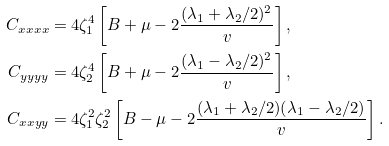<formula> <loc_0><loc_0><loc_500><loc_500>C _ { x x x x } & = 4 \zeta _ { 1 } ^ { 4 } \left [ B + \mu - 2 \frac { ( \lambda _ { 1 } + \lambda _ { 2 } / 2 ) ^ { 2 } } { v } \right ] , \\ C _ { y y y y } & = 4 \zeta _ { 2 } ^ { 4 } \left [ B + \mu - 2 \frac { ( \lambda _ { 1 } - \lambda _ { 2 } / 2 ) ^ { 2 } } { v } \right ] , \\ C _ { x x y y } & = 4 \zeta _ { 1 } ^ { 2 } \zeta _ { 2 } ^ { 2 } \left [ B - \mu - 2 \frac { ( \lambda _ { 1 } + \lambda _ { 2 } / 2 ) ( \lambda _ { 1 } - \lambda _ { 2 } / 2 ) } { v } \right ] .</formula> 